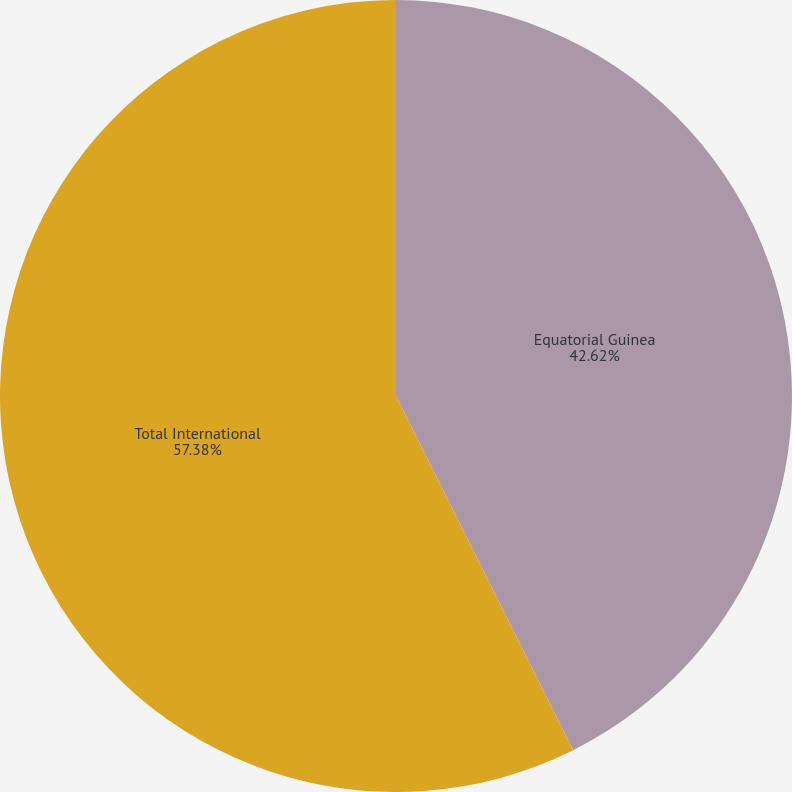Convert chart. <chart><loc_0><loc_0><loc_500><loc_500><pie_chart><fcel>Equatorial Guinea<fcel>Total International<nl><fcel>42.62%<fcel>57.38%<nl></chart> 